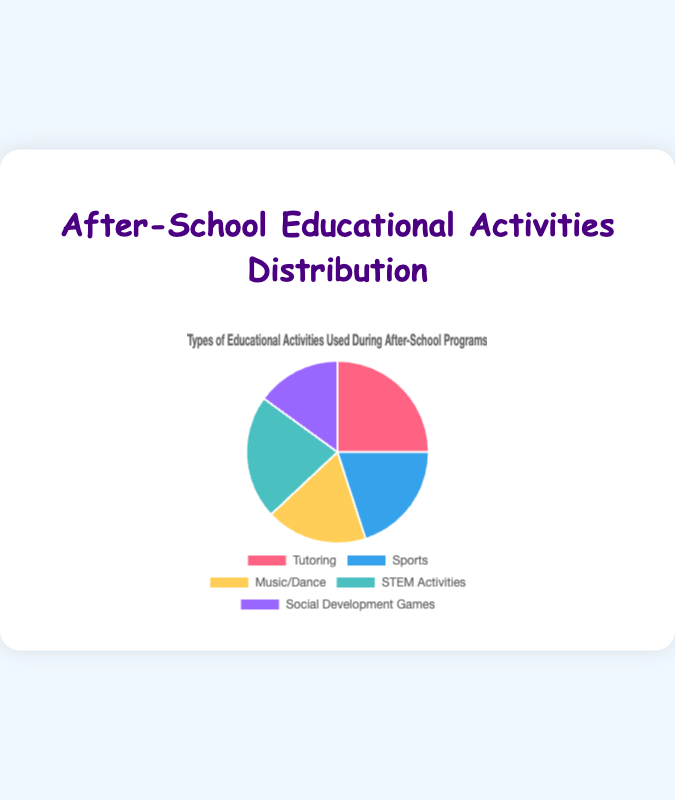Which activity has the highest percentage? The figure shows different activities and their corresponding percentages. "Tutoring" has the highest percentage, as indicated by the largest slice of the pie chart.
Answer: Tutoring Which activity has the smallest percentage? By observing the pie chart, "Social Development Games" has the smallest percentage because its slice is the smallest among all activities.
Answer: Social Development Games What is the total percentage of STEM Activities and Sports combined? The pie chart indicates that STEM Activities account for 22%, and Sports account for 20%. Adding these percentages together gives 22% + 20% = 42%.
Answer: 42% How much more percentage does Tutoring have compared to Music/Dance? Tutoring has 25%, and Music/Dance has 18%. The difference is 25% - 18% = 7%.
Answer: 7% Is the percentage of STEM Activities greater than the percentage of Sports? The pie chart shows that STEM Activities have a percentage of 22% and Sports have a percentage of 20%. Since 22% is greater than 20%, the percentage of STEM Activities is indeed greater.
Answer: Yes Arrange the activities in descending order of their percentage. The descending order based on the percentage values shown in the pie chart is Tutoring (25%), STEM Activities (22%), Sports (20%), Music/Dance (18%), and Social Development Games (15%).
Answer: Tutoring, STEM Activities, Sports, Music/Dance, Social Development Games What percentage of activities are non-STEM related? To find the non-STEM percentage, we sum the percentages of Tutoring, Sports, Music/Dance, and Social Development Games: 25% + 20% + 18% + 15% = 78%.
Answer: 78% What visual clue indicates that Sports has a smaller percentage than Tutoring? The visual size of each slice in the pie chart indicates the percentage representation. The slice for Sports is visibly smaller than the slice for Tutoring.
Answer: Smaller slice What is the combined percentage of STEM Activities, Music/Dance, and Social Development Games? Adding the percentages for these activities: STEM Activities (22%), Music/Dance (18%), and Social Development Games (15%), we get 22% + 18% + 15% = 55%.
Answer: 55% What percentage difference exists between the activity with the highest and lowest percentage? The highest percentage is for Tutoring (25%), and the lowest is for Social Development Games (15%). The difference is 25% - 15% = 10%.
Answer: 10% 